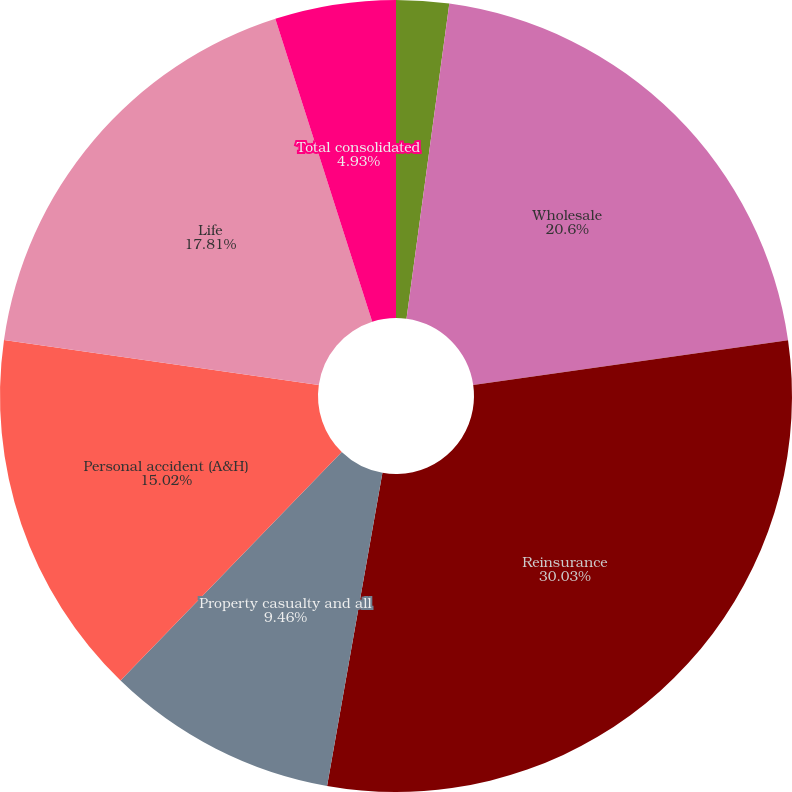<chart> <loc_0><loc_0><loc_500><loc_500><pie_chart><fcel>Retail P&C<fcel>Wholesale<fcel>Reinsurance<fcel>Property casualty and all<fcel>Personal accident (A&H)<fcel>Life<fcel>Total consolidated<nl><fcel>2.15%<fcel>20.6%<fcel>30.04%<fcel>9.46%<fcel>15.02%<fcel>17.81%<fcel>4.93%<nl></chart> 